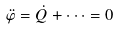<formula> <loc_0><loc_0><loc_500><loc_500>\ddot { \varphi } = \dot { Q } + \dots = 0</formula> 